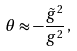<formula> <loc_0><loc_0><loc_500><loc_500>\theta \approx - \frac { \tilde { g } ^ { 2 } } { g ^ { 2 } } \, ,</formula> 